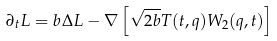<formula> <loc_0><loc_0><loc_500><loc_500>\partial _ { t } L = b \Delta L - \nabla \left [ \sqrt { 2 b } { T } ( t , q ) W _ { 2 } ( q , t ) \right ]</formula> 